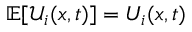<formula> <loc_0><loc_0><loc_500><loc_500>\mathbb { E } [ { \mathcal { U } } _ { i } ( x , t ) ] = U _ { i } ( x , t )</formula> 